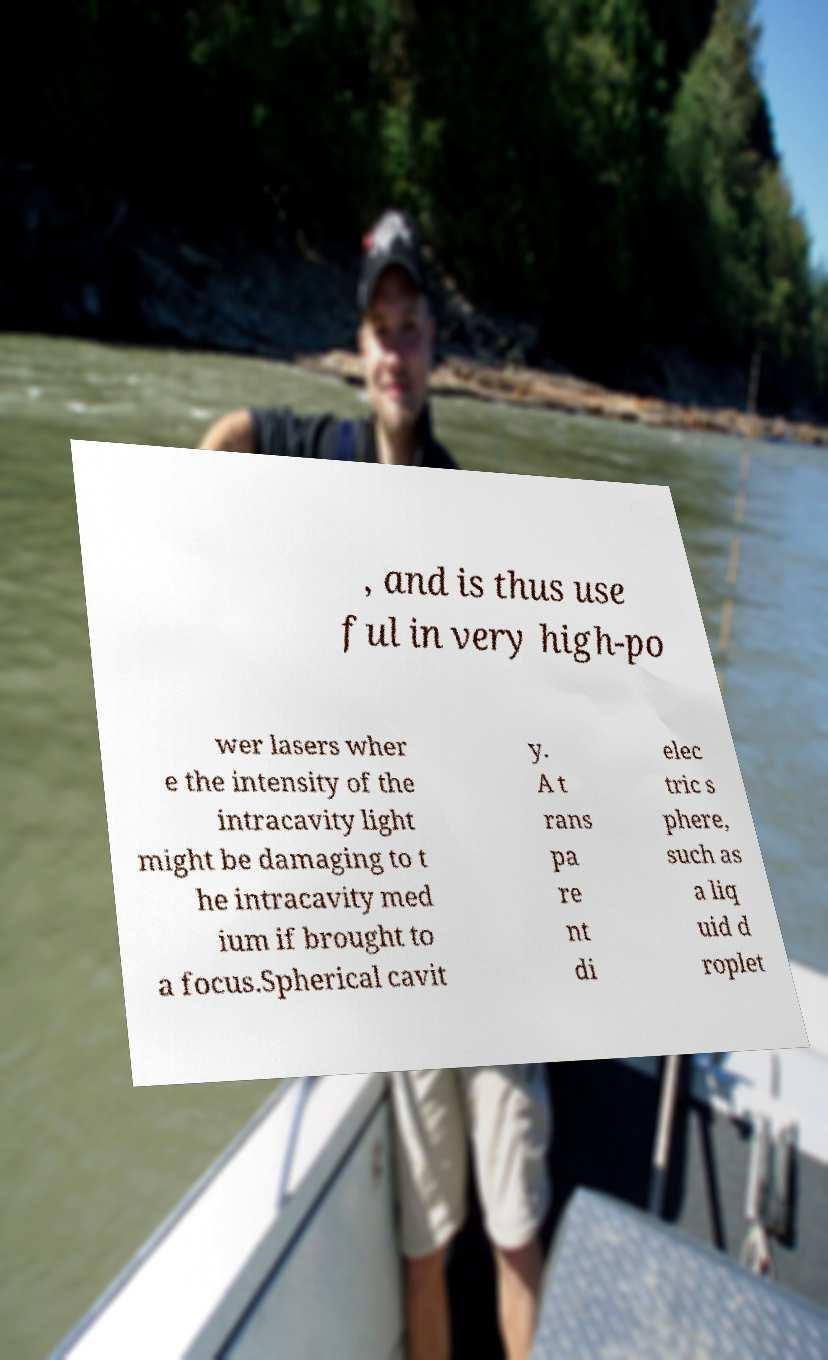Could you extract and type out the text from this image? , and is thus use ful in very high-po wer lasers wher e the intensity of the intracavity light might be damaging to t he intracavity med ium if brought to a focus.Spherical cavit y. A t rans pa re nt di elec tric s phere, such as a liq uid d roplet 